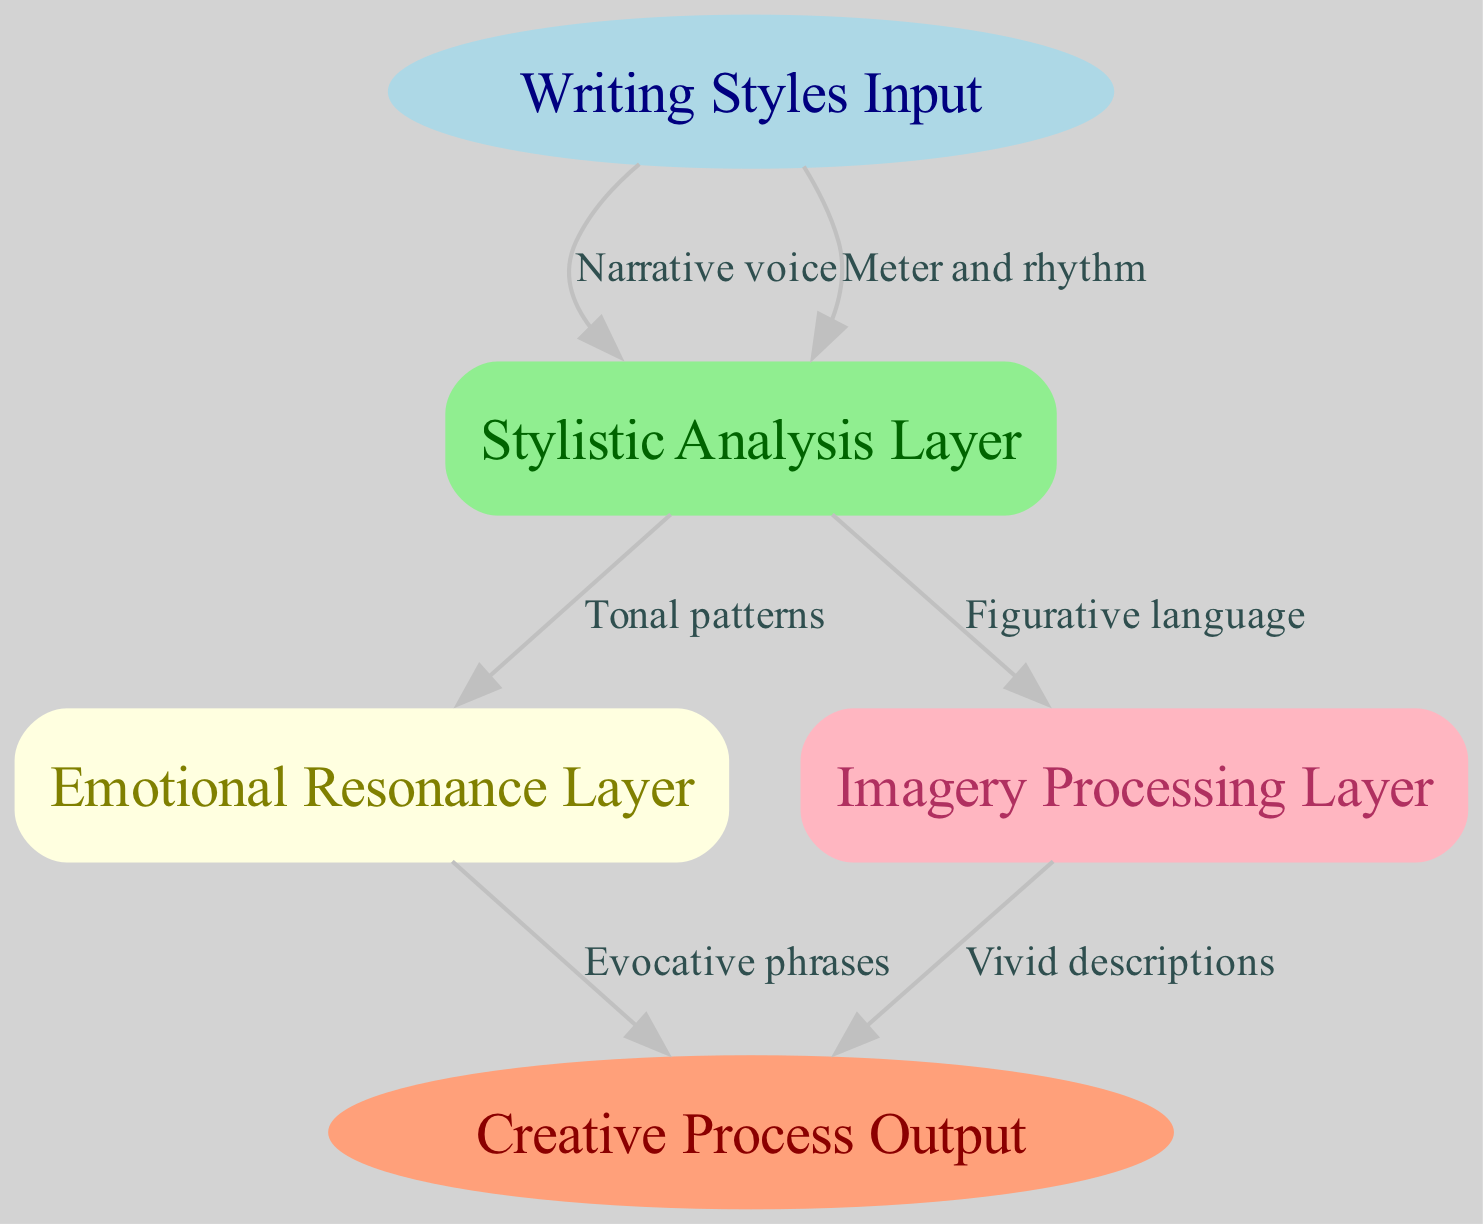What are the names of the layers in this diagram? The diagram contains three layers: Stylistic Analysis Layer, Emotional Resonance Layer, and Imagery Processing Layer. These can be found listed between the input and output nodes.
Answer: Stylistic Analysis Layer, Emotional Resonance Layer, Imagery Processing Layer How many input styles are depicted in this diagram? There is one input node labeled "Writing Styles Input." This represents the different writing styles being analyzed in the neural network.
Answer: One Which layer is directly influenced by "Narrative voice"? The "Narrative voice" edge points from the "Writing Styles Input" node to the "Stylistic Analysis Layer." This indicates that the narrative voice directly influences this first layer of analysis.
Answer: Stylistic Analysis Layer What types of outputs are generated from the layers? The outputs include "Evocative phrases" from the Emotional Resonance Layer and "Vivid descriptions" from the Imagery Processing Layer, which are the final outputs of the creative process.
Answer: Evocative phrases and Vivid descriptions How many edges connect the layers to the output in this diagram? Upon examining the diagram, there are two edges leading to the output node: one from the Emotional Resonance Layer and another from the Imagery Processing Layer. Therefore, the total number of edges connecting to the output is two.
Answer: Two Which layer processes "Figurative language"? The edge labeled "Figurative language" connects the Stylistic Analysis Layer to the Imagery Processing Layer, indicating that this layer is responsible for processing figurative language.
Answer: Imagery Processing Layer Identify the relationship between the "Stylistic Analysis Layer" and the "Emotional Resonance Layer". The "Tonal patterns" edge connects the "Stylistic Analysis Layer" to the "Emotional Resonance Layer," signifying that tonal patterns, analyzed in the first layer, influence the emotional resonance in the second layer.
Answer: Tonal patterns What color represents the "Creative Process Output" node? The "Creative Process Output" node is depicted in lightsalmon color as per the node styles specified in the diagram.
Answer: Lightsalmon 